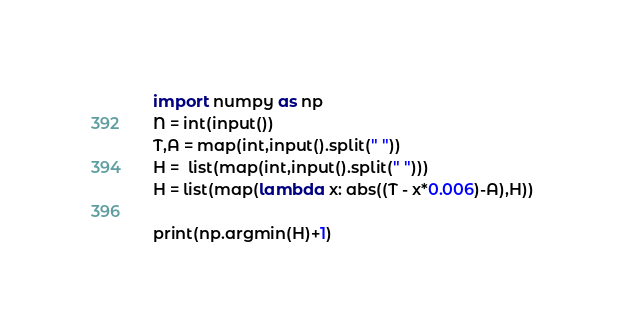<code> <loc_0><loc_0><loc_500><loc_500><_Python_>import numpy as np
N = int(input())
T,A = map(int,input().split(" "))
H =  list(map(int,input().split(" ")))
H = list(map(lambda x: abs((T - x*0.006)-A),H))

print(np.argmin(H)+1)
</code> 